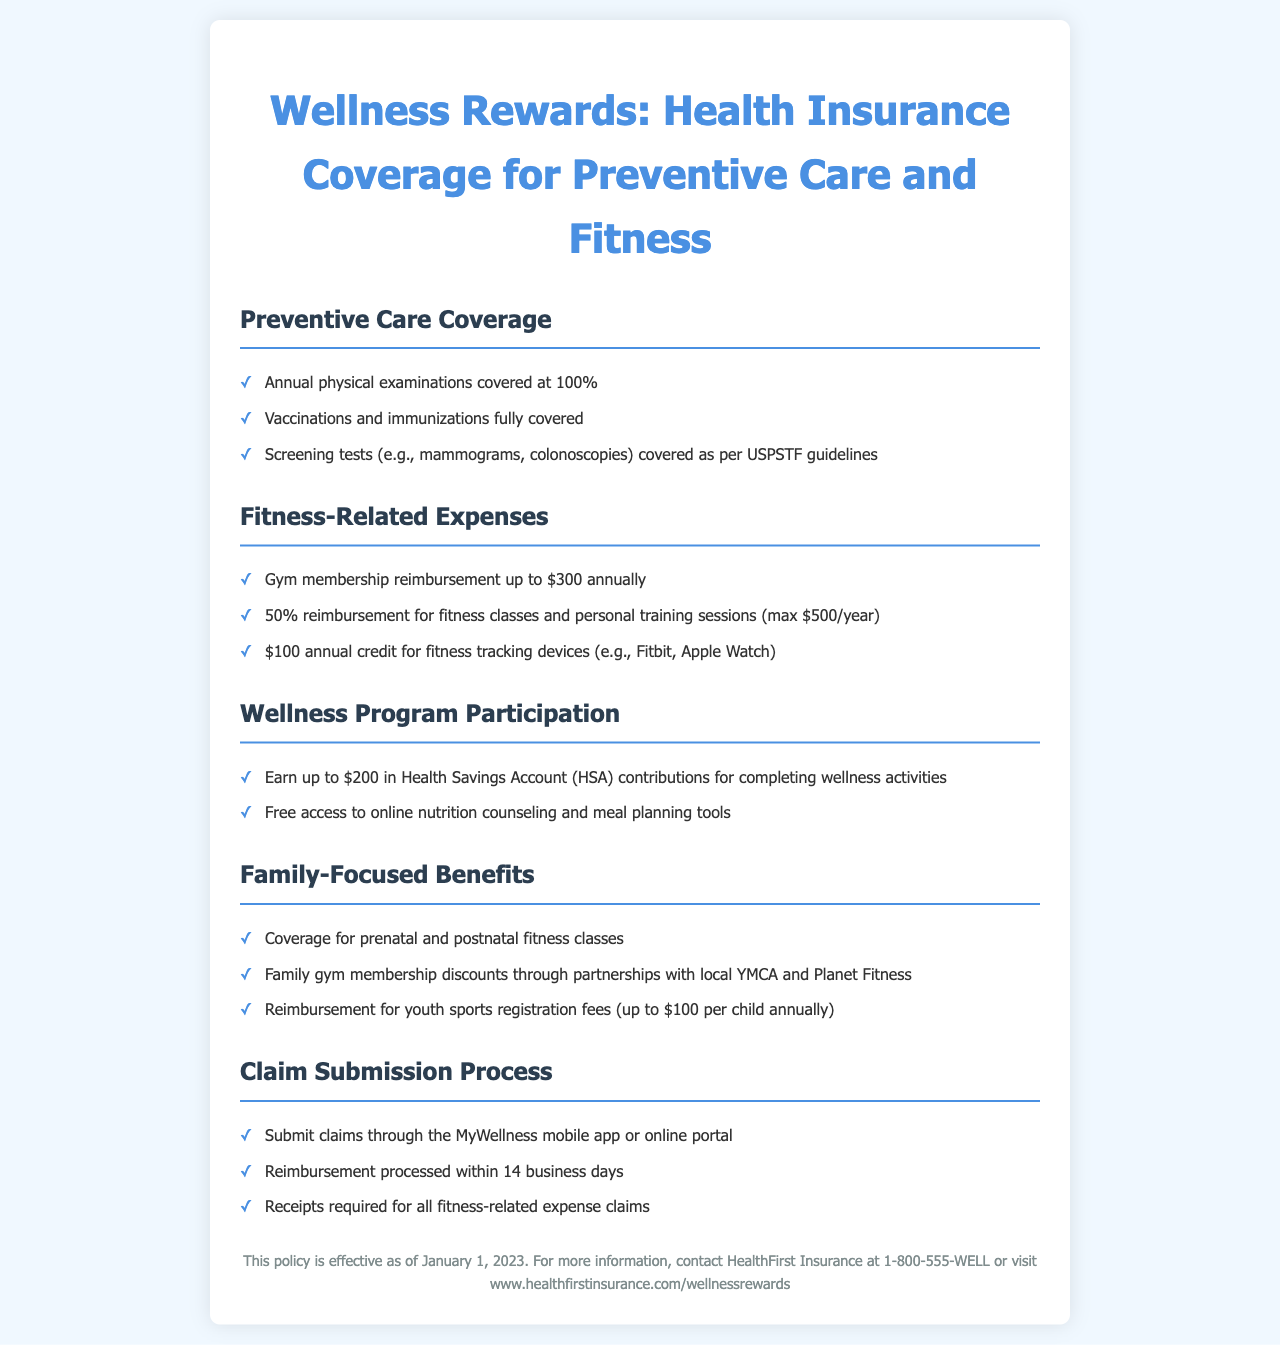What is the coverage for annual physical examinations? Annual physical examinations are covered at 100% as stated in the document.
Answer: 100% What is the maximum reimbursement for gym memberships? The document specifies a maximum reimbursement of $300 annually for gym memberships.
Answer: $300 How much can you earn in Health Savings Account contributions? You can earn up to $200 in Health Savings Account contributions for completing wellness activities according to the document.
Answer: $200 What age range do the youth sports registration fee reimbursements cover? The document mentions reimbursement for youth sports registration fees, which apply per child, indicating it targets children.
Answer: children What is the reimbursement rate for fitness classes and personal training sessions? The document states there is a 50% reimbursement for fitness classes and personal training sessions, capped at $500 per year.
Answer: 50% What online tools are provided free of charge? The document indicates free access to online nutrition counseling and meal planning tools.
Answer: nutrition counseling and meal planning tools How long does reimbursement processing take? The document specifies that reimbursements are processed within 14 business days.
Answer: 14 business days What type of fitness-related device can receive an annual credit? According to the document, an annual credit of $100 is available for fitness tracking devices like a Fitbit or Apple Watch.
Answer: fitness tracking devices Which organization provides family gym membership discounts? The document mentions that discounts are available through partnerships with local YMCA and Planet Fitness.
Answer: YMCA and Planet Fitness 